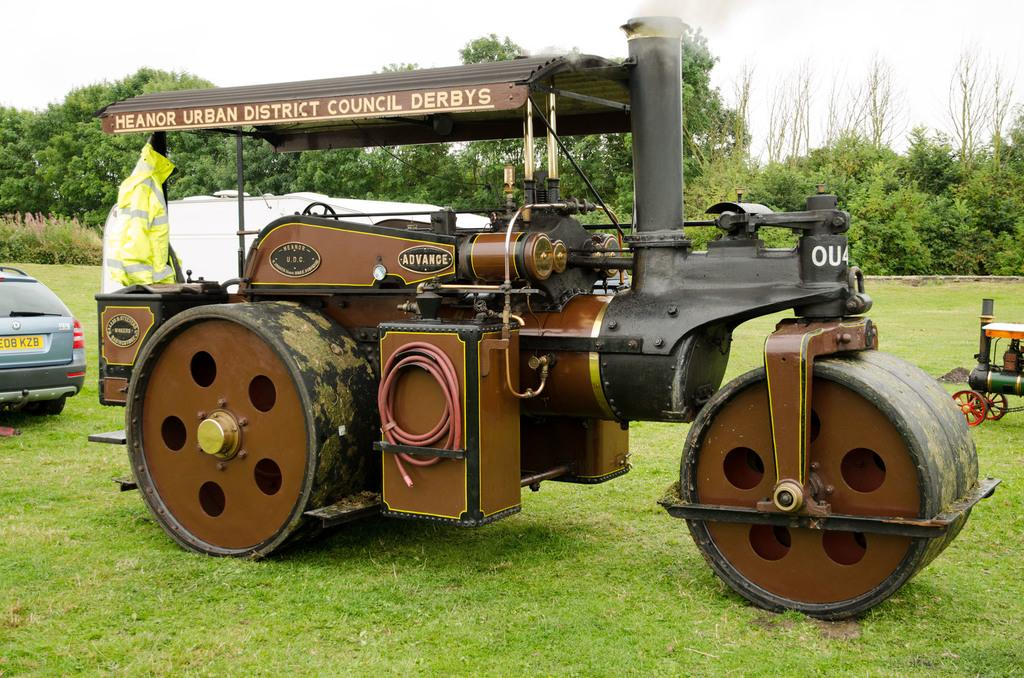What type of vehicles can be seen on the grass in the image? There are vehicles on the grass in the image, but the specific type of vehicles is not mentioned. What kind of temporary shelter is present in the image? There is a tent house in the image. What type of vegetation is visible in the image? There are trees in the image. What is visible in the background of the image? The sky is visible in the image. Can you see any drains in the image? There is no mention of drains in the image, so we cannot determine if any are present. Are there any clams visible in the image? There is no mention of clams in the image, so we cannot determine if any are present. 